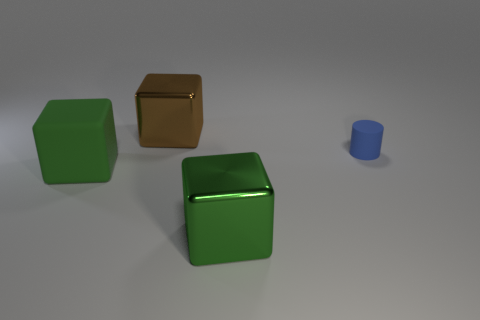There is a large brown thing; is it the same shape as the small blue matte object behind the green matte cube?
Make the answer very short. No. What number of other things are the same size as the matte cylinder?
Your answer should be compact. 0. How many brown objects are either big metal things or small cylinders?
Your response must be concise. 1. How many things are right of the big matte cube and in front of the small thing?
Make the answer very short. 1. What is the material of the green object left of the cube that is right of the big metal object that is behind the tiny blue matte cylinder?
Your answer should be very brief. Rubber. What number of large brown cubes have the same material as the big brown object?
Provide a short and direct response. 0. There is a big object that is the same color as the rubber block; what is its material?
Ensure brevity in your answer.  Metal. There is a big brown metal thing; are there any cylinders behind it?
Ensure brevity in your answer.  No. Is there another gray object of the same shape as the tiny rubber object?
Offer a very short reply. No. Does the big metal thing to the left of the big green shiny thing have the same shape as the rubber thing to the left of the tiny blue rubber thing?
Keep it short and to the point. Yes. 